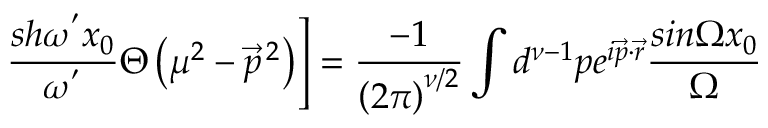Convert formula to latex. <formula><loc_0><loc_0><loc_500><loc_500>\frac { s h { \omega } ^ { ^ { \prime } } x _ { 0 } } { { \omega } ^ { ^ { \prime } } } \Theta \left ( { \mu } ^ { 2 } - { \vec { p } } ^ { \, 2 } \right ) \right ] = \frac { - 1 } { \left ( 2 \pi \right ) ^ { \nu / 2 } } \int d ^ { \nu - 1 } p e ^ { i \vec { p } \cdot \vec { r } } \frac { \sin \Omega x _ { 0 } } { \Omega }</formula> 